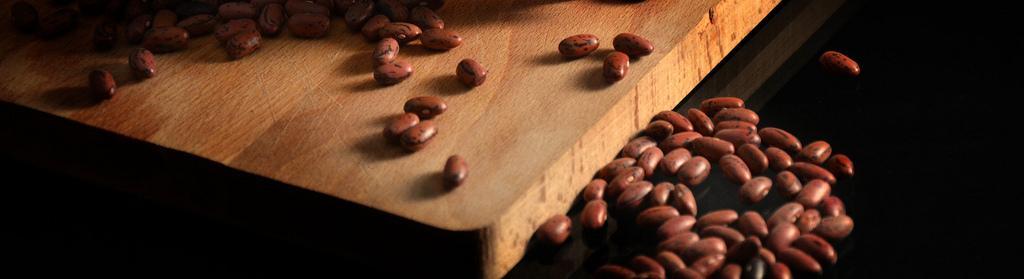Could you give a brief overview of what you see in this image? In the picture we can see a wooden plank on it we can see some beans which are brown in color and beside it also we can see some beans on the floor. 